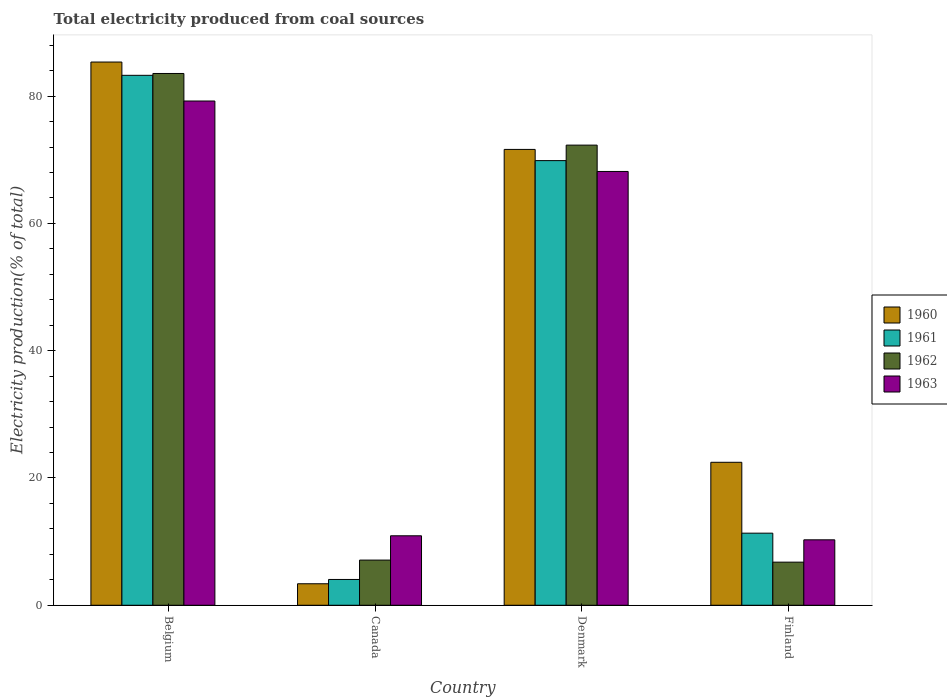How many different coloured bars are there?
Give a very brief answer. 4. How many groups of bars are there?
Your response must be concise. 4. What is the total electricity produced in 1961 in Finland?
Provide a succinct answer. 11.33. Across all countries, what is the maximum total electricity produced in 1960?
Offer a terse response. 85.36. Across all countries, what is the minimum total electricity produced in 1963?
Keep it short and to the point. 10.28. In which country was the total electricity produced in 1961 minimum?
Keep it short and to the point. Canada. What is the total total electricity produced in 1962 in the graph?
Ensure brevity in your answer.  169.73. What is the difference between the total electricity produced in 1961 in Belgium and that in Canada?
Your response must be concise. 79.21. What is the difference between the total electricity produced in 1961 in Belgium and the total electricity produced in 1962 in Canada?
Your response must be concise. 76.17. What is the average total electricity produced in 1961 per country?
Your answer should be compact. 42.13. What is the difference between the total electricity produced of/in 1960 and total electricity produced of/in 1962 in Belgium?
Keep it short and to the point. 1.8. What is the ratio of the total electricity produced in 1960 in Canada to that in Denmark?
Provide a short and direct response. 0.05. What is the difference between the highest and the second highest total electricity produced in 1961?
Offer a terse response. -71.94. What is the difference between the highest and the lowest total electricity produced in 1961?
Your answer should be compact. 79.21. In how many countries, is the total electricity produced in 1963 greater than the average total electricity produced in 1963 taken over all countries?
Ensure brevity in your answer.  2. Is it the case that in every country, the sum of the total electricity produced in 1962 and total electricity produced in 1960 is greater than the sum of total electricity produced in 1963 and total electricity produced in 1961?
Provide a short and direct response. No. How many bars are there?
Your response must be concise. 16. Are all the bars in the graph horizontal?
Offer a very short reply. No. How many countries are there in the graph?
Keep it short and to the point. 4. Are the values on the major ticks of Y-axis written in scientific E-notation?
Your response must be concise. No. Where does the legend appear in the graph?
Your answer should be compact. Center right. How are the legend labels stacked?
Make the answer very short. Vertical. What is the title of the graph?
Provide a succinct answer. Total electricity produced from coal sources. Does "2005" appear as one of the legend labels in the graph?
Give a very brief answer. No. What is the label or title of the Y-axis?
Offer a very short reply. Electricity production(% of total). What is the Electricity production(% of total) of 1960 in Belgium?
Provide a short and direct response. 85.36. What is the Electricity production(% of total) in 1961 in Belgium?
Keep it short and to the point. 83.27. What is the Electricity production(% of total) of 1962 in Belgium?
Ensure brevity in your answer.  83.56. What is the Electricity production(% of total) of 1963 in Belgium?
Provide a short and direct response. 79.23. What is the Electricity production(% of total) of 1960 in Canada?
Offer a terse response. 3.38. What is the Electricity production(% of total) in 1961 in Canada?
Offer a terse response. 4.05. What is the Electricity production(% of total) in 1962 in Canada?
Provide a succinct answer. 7.1. What is the Electricity production(% of total) of 1963 in Canada?
Provide a short and direct response. 10.92. What is the Electricity production(% of total) in 1960 in Denmark?
Ensure brevity in your answer.  71.62. What is the Electricity production(% of total) of 1961 in Denmark?
Offer a terse response. 69.86. What is the Electricity production(% of total) of 1962 in Denmark?
Offer a very short reply. 72.3. What is the Electricity production(% of total) in 1963 in Denmark?
Keep it short and to the point. 68.16. What is the Electricity production(% of total) of 1960 in Finland?
Your response must be concise. 22.46. What is the Electricity production(% of total) in 1961 in Finland?
Offer a terse response. 11.33. What is the Electricity production(% of total) of 1962 in Finland?
Your answer should be compact. 6.78. What is the Electricity production(% of total) of 1963 in Finland?
Provide a short and direct response. 10.28. Across all countries, what is the maximum Electricity production(% of total) of 1960?
Ensure brevity in your answer.  85.36. Across all countries, what is the maximum Electricity production(% of total) in 1961?
Your response must be concise. 83.27. Across all countries, what is the maximum Electricity production(% of total) in 1962?
Ensure brevity in your answer.  83.56. Across all countries, what is the maximum Electricity production(% of total) of 1963?
Ensure brevity in your answer.  79.23. Across all countries, what is the minimum Electricity production(% of total) in 1960?
Keep it short and to the point. 3.38. Across all countries, what is the minimum Electricity production(% of total) of 1961?
Offer a terse response. 4.05. Across all countries, what is the minimum Electricity production(% of total) in 1962?
Make the answer very short. 6.78. Across all countries, what is the minimum Electricity production(% of total) of 1963?
Keep it short and to the point. 10.28. What is the total Electricity production(% of total) in 1960 in the graph?
Provide a short and direct response. 182.82. What is the total Electricity production(% of total) of 1961 in the graph?
Offer a very short reply. 168.51. What is the total Electricity production(% of total) in 1962 in the graph?
Offer a terse response. 169.73. What is the total Electricity production(% of total) of 1963 in the graph?
Provide a short and direct response. 168.59. What is the difference between the Electricity production(% of total) in 1960 in Belgium and that in Canada?
Give a very brief answer. 81.98. What is the difference between the Electricity production(% of total) of 1961 in Belgium and that in Canada?
Your response must be concise. 79.21. What is the difference between the Electricity production(% of total) of 1962 in Belgium and that in Canada?
Ensure brevity in your answer.  76.46. What is the difference between the Electricity production(% of total) in 1963 in Belgium and that in Canada?
Your answer should be compact. 68.31. What is the difference between the Electricity production(% of total) of 1960 in Belgium and that in Denmark?
Your response must be concise. 13.73. What is the difference between the Electricity production(% of total) of 1961 in Belgium and that in Denmark?
Provide a short and direct response. 13.4. What is the difference between the Electricity production(% of total) in 1962 in Belgium and that in Denmark?
Provide a short and direct response. 11.26. What is the difference between the Electricity production(% of total) of 1963 in Belgium and that in Denmark?
Provide a short and direct response. 11.07. What is the difference between the Electricity production(% of total) in 1960 in Belgium and that in Finland?
Keep it short and to the point. 62.89. What is the difference between the Electricity production(% of total) of 1961 in Belgium and that in Finland?
Your answer should be very brief. 71.94. What is the difference between the Electricity production(% of total) of 1962 in Belgium and that in Finland?
Offer a terse response. 76.78. What is the difference between the Electricity production(% of total) of 1963 in Belgium and that in Finland?
Offer a very short reply. 68.95. What is the difference between the Electricity production(% of total) in 1960 in Canada and that in Denmark?
Your response must be concise. -68.25. What is the difference between the Electricity production(% of total) in 1961 in Canada and that in Denmark?
Make the answer very short. -65.81. What is the difference between the Electricity production(% of total) in 1962 in Canada and that in Denmark?
Provide a succinct answer. -65.2. What is the difference between the Electricity production(% of total) of 1963 in Canada and that in Denmark?
Your answer should be compact. -57.24. What is the difference between the Electricity production(% of total) of 1960 in Canada and that in Finland?
Offer a very short reply. -19.09. What is the difference between the Electricity production(% of total) of 1961 in Canada and that in Finland?
Provide a succinct answer. -7.27. What is the difference between the Electricity production(% of total) of 1962 in Canada and that in Finland?
Your response must be concise. 0.32. What is the difference between the Electricity production(% of total) of 1963 in Canada and that in Finland?
Your response must be concise. 0.63. What is the difference between the Electricity production(% of total) of 1960 in Denmark and that in Finland?
Your answer should be very brief. 49.16. What is the difference between the Electricity production(% of total) of 1961 in Denmark and that in Finland?
Offer a very short reply. 58.54. What is the difference between the Electricity production(% of total) in 1962 in Denmark and that in Finland?
Provide a short and direct response. 65.53. What is the difference between the Electricity production(% of total) in 1963 in Denmark and that in Finland?
Your response must be concise. 57.88. What is the difference between the Electricity production(% of total) in 1960 in Belgium and the Electricity production(% of total) in 1961 in Canada?
Your answer should be compact. 81.3. What is the difference between the Electricity production(% of total) of 1960 in Belgium and the Electricity production(% of total) of 1962 in Canada?
Offer a terse response. 78.26. What is the difference between the Electricity production(% of total) of 1960 in Belgium and the Electricity production(% of total) of 1963 in Canada?
Your answer should be very brief. 74.44. What is the difference between the Electricity production(% of total) in 1961 in Belgium and the Electricity production(% of total) in 1962 in Canada?
Your answer should be very brief. 76.17. What is the difference between the Electricity production(% of total) in 1961 in Belgium and the Electricity production(% of total) in 1963 in Canada?
Give a very brief answer. 72.35. What is the difference between the Electricity production(% of total) of 1962 in Belgium and the Electricity production(% of total) of 1963 in Canada?
Your answer should be very brief. 72.64. What is the difference between the Electricity production(% of total) in 1960 in Belgium and the Electricity production(% of total) in 1961 in Denmark?
Keep it short and to the point. 15.49. What is the difference between the Electricity production(% of total) in 1960 in Belgium and the Electricity production(% of total) in 1962 in Denmark?
Provide a short and direct response. 13.05. What is the difference between the Electricity production(% of total) in 1960 in Belgium and the Electricity production(% of total) in 1963 in Denmark?
Offer a very short reply. 17.19. What is the difference between the Electricity production(% of total) in 1961 in Belgium and the Electricity production(% of total) in 1962 in Denmark?
Keep it short and to the point. 10.97. What is the difference between the Electricity production(% of total) of 1961 in Belgium and the Electricity production(% of total) of 1963 in Denmark?
Give a very brief answer. 15.11. What is the difference between the Electricity production(% of total) in 1962 in Belgium and the Electricity production(% of total) in 1963 in Denmark?
Provide a short and direct response. 15.4. What is the difference between the Electricity production(% of total) of 1960 in Belgium and the Electricity production(% of total) of 1961 in Finland?
Your response must be concise. 74.03. What is the difference between the Electricity production(% of total) of 1960 in Belgium and the Electricity production(% of total) of 1962 in Finland?
Make the answer very short. 78.58. What is the difference between the Electricity production(% of total) of 1960 in Belgium and the Electricity production(% of total) of 1963 in Finland?
Your answer should be very brief. 75.07. What is the difference between the Electricity production(% of total) of 1961 in Belgium and the Electricity production(% of total) of 1962 in Finland?
Give a very brief answer. 76.49. What is the difference between the Electricity production(% of total) in 1961 in Belgium and the Electricity production(% of total) in 1963 in Finland?
Provide a short and direct response. 72.98. What is the difference between the Electricity production(% of total) in 1962 in Belgium and the Electricity production(% of total) in 1963 in Finland?
Offer a terse response. 73.27. What is the difference between the Electricity production(% of total) in 1960 in Canada and the Electricity production(% of total) in 1961 in Denmark?
Give a very brief answer. -66.49. What is the difference between the Electricity production(% of total) in 1960 in Canada and the Electricity production(% of total) in 1962 in Denmark?
Offer a very short reply. -68.92. What is the difference between the Electricity production(% of total) of 1960 in Canada and the Electricity production(% of total) of 1963 in Denmark?
Your answer should be very brief. -64.78. What is the difference between the Electricity production(% of total) of 1961 in Canada and the Electricity production(% of total) of 1962 in Denmark?
Offer a very short reply. -68.25. What is the difference between the Electricity production(% of total) in 1961 in Canada and the Electricity production(% of total) in 1963 in Denmark?
Provide a succinct answer. -64.11. What is the difference between the Electricity production(% of total) of 1962 in Canada and the Electricity production(% of total) of 1963 in Denmark?
Keep it short and to the point. -61.06. What is the difference between the Electricity production(% of total) in 1960 in Canada and the Electricity production(% of total) in 1961 in Finland?
Your answer should be compact. -7.95. What is the difference between the Electricity production(% of total) of 1960 in Canada and the Electricity production(% of total) of 1962 in Finland?
Your response must be concise. -3.4. What is the difference between the Electricity production(% of total) of 1960 in Canada and the Electricity production(% of total) of 1963 in Finland?
Your answer should be very brief. -6.91. What is the difference between the Electricity production(% of total) in 1961 in Canada and the Electricity production(% of total) in 1962 in Finland?
Your response must be concise. -2.72. What is the difference between the Electricity production(% of total) of 1961 in Canada and the Electricity production(% of total) of 1963 in Finland?
Offer a very short reply. -6.23. What is the difference between the Electricity production(% of total) in 1962 in Canada and the Electricity production(% of total) in 1963 in Finland?
Your answer should be compact. -3.18. What is the difference between the Electricity production(% of total) in 1960 in Denmark and the Electricity production(% of total) in 1961 in Finland?
Offer a very short reply. 60.3. What is the difference between the Electricity production(% of total) of 1960 in Denmark and the Electricity production(% of total) of 1962 in Finland?
Ensure brevity in your answer.  64.85. What is the difference between the Electricity production(% of total) in 1960 in Denmark and the Electricity production(% of total) in 1963 in Finland?
Your response must be concise. 61.34. What is the difference between the Electricity production(% of total) in 1961 in Denmark and the Electricity production(% of total) in 1962 in Finland?
Make the answer very short. 63.09. What is the difference between the Electricity production(% of total) in 1961 in Denmark and the Electricity production(% of total) in 1963 in Finland?
Provide a succinct answer. 59.58. What is the difference between the Electricity production(% of total) in 1962 in Denmark and the Electricity production(% of total) in 1963 in Finland?
Make the answer very short. 62.02. What is the average Electricity production(% of total) in 1960 per country?
Offer a terse response. 45.71. What is the average Electricity production(% of total) of 1961 per country?
Your answer should be compact. 42.13. What is the average Electricity production(% of total) of 1962 per country?
Your answer should be compact. 42.43. What is the average Electricity production(% of total) of 1963 per country?
Make the answer very short. 42.15. What is the difference between the Electricity production(% of total) of 1960 and Electricity production(% of total) of 1961 in Belgium?
Keep it short and to the point. 2.09. What is the difference between the Electricity production(% of total) of 1960 and Electricity production(% of total) of 1962 in Belgium?
Give a very brief answer. 1.8. What is the difference between the Electricity production(% of total) in 1960 and Electricity production(% of total) in 1963 in Belgium?
Your answer should be very brief. 6.12. What is the difference between the Electricity production(% of total) of 1961 and Electricity production(% of total) of 1962 in Belgium?
Provide a short and direct response. -0.29. What is the difference between the Electricity production(% of total) in 1961 and Electricity production(% of total) in 1963 in Belgium?
Make the answer very short. 4.04. What is the difference between the Electricity production(% of total) of 1962 and Electricity production(% of total) of 1963 in Belgium?
Offer a very short reply. 4.33. What is the difference between the Electricity production(% of total) in 1960 and Electricity production(% of total) in 1961 in Canada?
Your answer should be very brief. -0.68. What is the difference between the Electricity production(% of total) in 1960 and Electricity production(% of total) in 1962 in Canada?
Keep it short and to the point. -3.72. What is the difference between the Electricity production(% of total) of 1960 and Electricity production(% of total) of 1963 in Canada?
Offer a very short reply. -7.54. What is the difference between the Electricity production(% of total) in 1961 and Electricity production(% of total) in 1962 in Canada?
Ensure brevity in your answer.  -3.04. What is the difference between the Electricity production(% of total) of 1961 and Electricity production(% of total) of 1963 in Canada?
Give a very brief answer. -6.86. What is the difference between the Electricity production(% of total) of 1962 and Electricity production(% of total) of 1963 in Canada?
Offer a terse response. -3.82. What is the difference between the Electricity production(% of total) of 1960 and Electricity production(% of total) of 1961 in Denmark?
Make the answer very short. 1.76. What is the difference between the Electricity production(% of total) of 1960 and Electricity production(% of total) of 1962 in Denmark?
Give a very brief answer. -0.68. What is the difference between the Electricity production(% of total) in 1960 and Electricity production(% of total) in 1963 in Denmark?
Offer a terse response. 3.46. What is the difference between the Electricity production(% of total) of 1961 and Electricity production(% of total) of 1962 in Denmark?
Keep it short and to the point. -2.44. What is the difference between the Electricity production(% of total) in 1961 and Electricity production(% of total) in 1963 in Denmark?
Give a very brief answer. 1.7. What is the difference between the Electricity production(% of total) in 1962 and Electricity production(% of total) in 1963 in Denmark?
Provide a succinct answer. 4.14. What is the difference between the Electricity production(% of total) in 1960 and Electricity production(% of total) in 1961 in Finland?
Provide a short and direct response. 11.14. What is the difference between the Electricity production(% of total) in 1960 and Electricity production(% of total) in 1962 in Finland?
Provide a short and direct response. 15.69. What is the difference between the Electricity production(% of total) of 1960 and Electricity production(% of total) of 1963 in Finland?
Give a very brief answer. 12.18. What is the difference between the Electricity production(% of total) of 1961 and Electricity production(% of total) of 1962 in Finland?
Keep it short and to the point. 4.55. What is the difference between the Electricity production(% of total) in 1961 and Electricity production(% of total) in 1963 in Finland?
Ensure brevity in your answer.  1.04. What is the difference between the Electricity production(% of total) in 1962 and Electricity production(% of total) in 1963 in Finland?
Make the answer very short. -3.51. What is the ratio of the Electricity production(% of total) in 1960 in Belgium to that in Canada?
Your answer should be very brief. 25.27. What is the ratio of the Electricity production(% of total) in 1961 in Belgium to that in Canada?
Provide a short and direct response. 20.54. What is the ratio of the Electricity production(% of total) in 1962 in Belgium to that in Canada?
Ensure brevity in your answer.  11.77. What is the ratio of the Electricity production(% of total) in 1963 in Belgium to that in Canada?
Give a very brief answer. 7.26. What is the ratio of the Electricity production(% of total) of 1960 in Belgium to that in Denmark?
Offer a very short reply. 1.19. What is the ratio of the Electricity production(% of total) in 1961 in Belgium to that in Denmark?
Make the answer very short. 1.19. What is the ratio of the Electricity production(% of total) of 1962 in Belgium to that in Denmark?
Provide a short and direct response. 1.16. What is the ratio of the Electricity production(% of total) of 1963 in Belgium to that in Denmark?
Provide a short and direct response. 1.16. What is the ratio of the Electricity production(% of total) in 1960 in Belgium to that in Finland?
Your answer should be very brief. 3.8. What is the ratio of the Electricity production(% of total) in 1961 in Belgium to that in Finland?
Keep it short and to the point. 7.35. What is the ratio of the Electricity production(% of total) of 1962 in Belgium to that in Finland?
Keep it short and to the point. 12.33. What is the ratio of the Electricity production(% of total) in 1963 in Belgium to that in Finland?
Your answer should be compact. 7.7. What is the ratio of the Electricity production(% of total) of 1960 in Canada to that in Denmark?
Your answer should be very brief. 0.05. What is the ratio of the Electricity production(% of total) in 1961 in Canada to that in Denmark?
Offer a terse response. 0.06. What is the ratio of the Electricity production(% of total) of 1962 in Canada to that in Denmark?
Offer a very short reply. 0.1. What is the ratio of the Electricity production(% of total) of 1963 in Canada to that in Denmark?
Ensure brevity in your answer.  0.16. What is the ratio of the Electricity production(% of total) in 1960 in Canada to that in Finland?
Keep it short and to the point. 0.15. What is the ratio of the Electricity production(% of total) in 1961 in Canada to that in Finland?
Offer a very short reply. 0.36. What is the ratio of the Electricity production(% of total) of 1962 in Canada to that in Finland?
Provide a short and direct response. 1.05. What is the ratio of the Electricity production(% of total) in 1963 in Canada to that in Finland?
Your answer should be very brief. 1.06. What is the ratio of the Electricity production(% of total) of 1960 in Denmark to that in Finland?
Provide a short and direct response. 3.19. What is the ratio of the Electricity production(% of total) of 1961 in Denmark to that in Finland?
Provide a short and direct response. 6.17. What is the ratio of the Electricity production(% of total) in 1962 in Denmark to that in Finland?
Offer a very short reply. 10.67. What is the ratio of the Electricity production(% of total) in 1963 in Denmark to that in Finland?
Keep it short and to the point. 6.63. What is the difference between the highest and the second highest Electricity production(% of total) in 1960?
Provide a short and direct response. 13.73. What is the difference between the highest and the second highest Electricity production(% of total) of 1961?
Provide a short and direct response. 13.4. What is the difference between the highest and the second highest Electricity production(% of total) in 1962?
Keep it short and to the point. 11.26. What is the difference between the highest and the second highest Electricity production(% of total) of 1963?
Offer a very short reply. 11.07. What is the difference between the highest and the lowest Electricity production(% of total) in 1960?
Your answer should be very brief. 81.98. What is the difference between the highest and the lowest Electricity production(% of total) in 1961?
Offer a terse response. 79.21. What is the difference between the highest and the lowest Electricity production(% of total) in 1962?
Provide a succinct answer. 76.78. What is the difference between the highest and the lowest Electricity production(% of total) in 1963?
Ensure brevity in your answer.  68.95. 